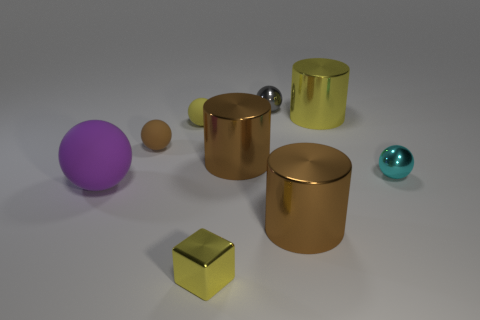What is the material of the sphere that is the same color as the metallic cube?
Give a very brief answer. Rubber. How many things are either tiny gray shiny things or yellow cylinders?
Make the answer very short. 2. Are there any other large matte blocks of the same color as the cube?
Provide a succinct answer. No. There is a small yellow thing in front of the big matte thing; how many objects are behind it?
Ensure brevity in your answer.  8. Are there more tiny red rubber spheres than yellow metallic things?
Keep it short and to the point. No. Are the brown ball and the purple thing made of the same material?
Provide a short and direct response. Yes. Are there the same number of large objects to the right of the small yellow metallic thing and brown objects?
Keep it short and to the point. Yes. What number of large brown cylinders have the same material as the small cube?
Make the answer very short. 2. Is the number of shiny balls less than the number of tiny brown rubber balls?
Your answer should be compact. No. Is the color of the big thing on the left side of the metal cube the same as the shiny block?
Your answer should be compact. No. 